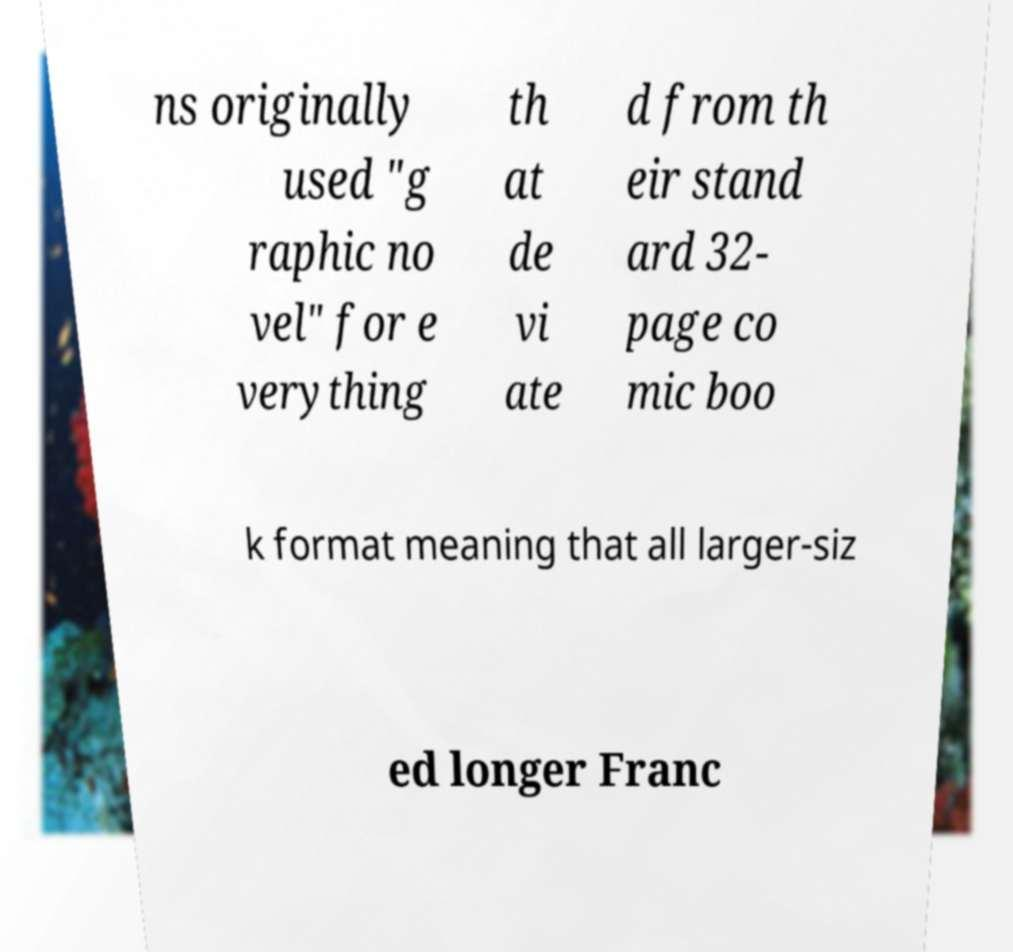Could you assist in decoding the text presented in this image and type it out clearly? ns originally used "g raphic no vel" for e verything th at de vi ate d from th eir stand ard 32- page co mic boo k format meaning that all larger-siz ed longer Franc 